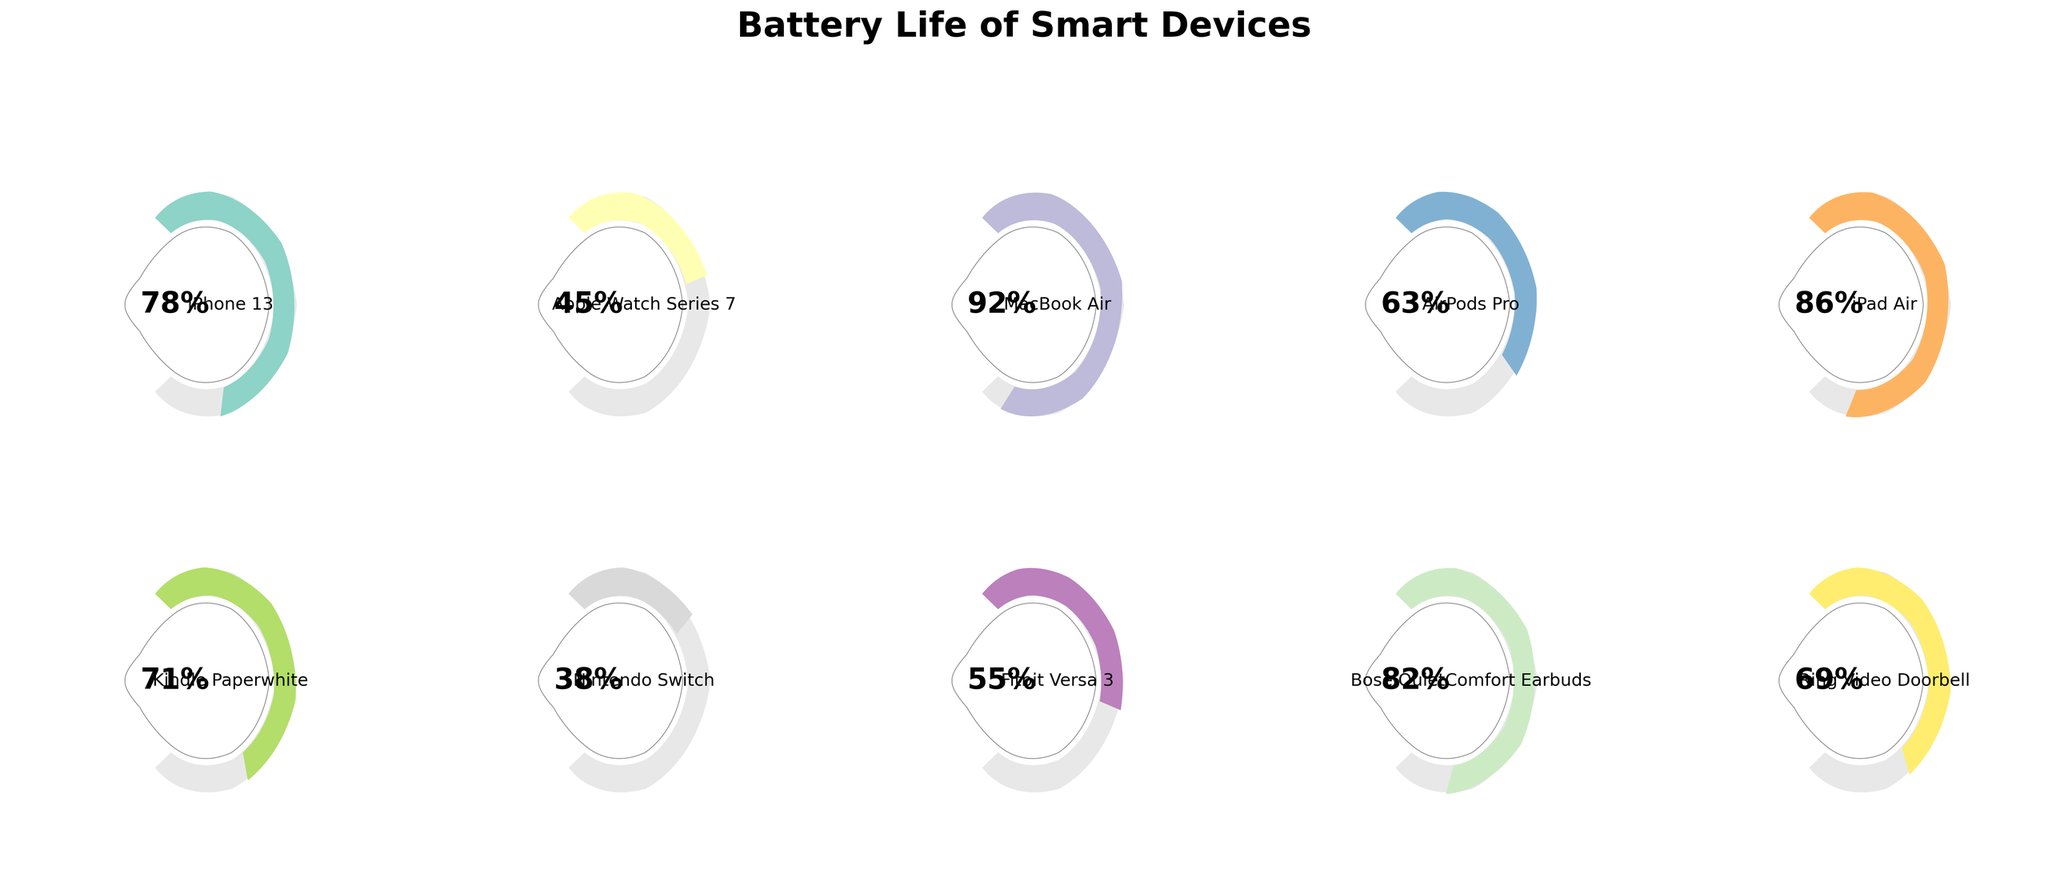How many devices are displayed in the figure? Count the number of gauges in the figure. Each gauge represents one device.
Answer: 10 Which device has the highest battery percentage? Look for the gauge with the largest angle and the highest percentage displayed in the center. The corresponding label will tell you the device.
Answer: MacBook Air What is the battery percentage of the Fitbit Versa 3? Locate the gauge labeled "Fitbit Versa 3" and read the percentage shown in the center of the circle.
Answer: 55% Which devices have a battery percentage below 50%? Identify gauges with angles less than 90 degrees and check their percentages. The corresponding labels will tell you the devices.
Answer: Apple Watch Series 7, Nintendo Switch How much higher is the battery percentage of the MacBook Air compared to the AirPods Pro? Subtract the battery percentage of the AirPods Pro from that of the MacBook Air.
Answer: 92% - 63% = 29% What is the average battery percentage of the iPhone 13, iPad Air, and Kindle Paperwhite? Add the battery percentages of these three devices and divide by 3. (78 + 86 + 71) / 3 = 235 / 3 = 78.33
Answer: 78.33% Arrange the devices with percentages above 80% in descending order. Identify gauges with percentages greater than 80%, list their devices and sort them from highest to lowest.
Answer: MacBook Air, Bose QuietComfort Earbuds, iPad Air, iPhone 13 How does the battery percentage of the Bose QuietComfort Earbuds compare to the Ring Video Doorbell? Identify both devices and compare their percentages. The Bose QuietComfort Earbuds have 82%, and the Ring Video Doorbell has 69%.
Answer: Greater What is the range of battery percentages displayed across all devices? Subtract the smallest battery percentage from the largest one. The largest is 92% (MacBook Air), and the smallest is 38% (Nintendo Switch).
Answer: 92% - 38% = 54% Are there more devices with battery percentages above 75% or below 75%? Count the number of devices with percentages above 75% and those below 75%, then compare the counts. There are 5 devices above 75% (iPhone 13, MacBook Air, iPad Air, Bose QuietComfort Earbuds, Kindle Paperwhite) and 5 devices below 75%.
Answer: Equal 